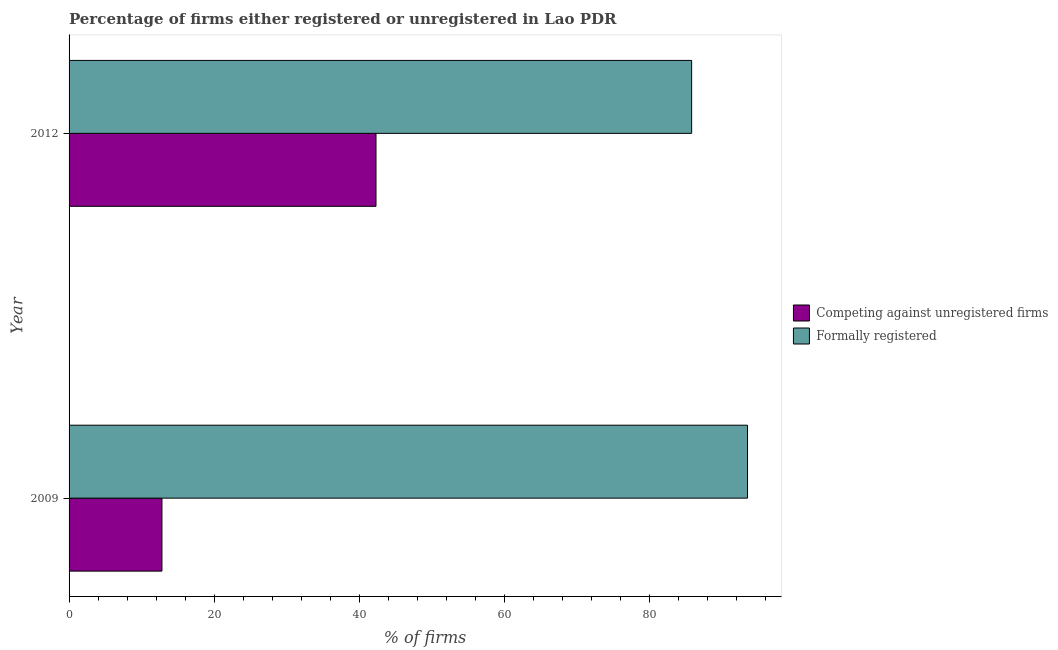How many different coloured bars are there?
Your response must be concise. 2. Are the number of bars per tick equal to the number of legend labels?
Ensure brevity in your answer.  Yes. How many bars are there on the 2nd tick from the top?
Provide a short and direct response. 2. How many bars are there on the 2nd tick from the bottom?
Provide a succinct answer. 2. In how many cases, is the number of bars for a given year not equal to the number of legend labels?
Offer a very short reply. 0. What is the percentage of formally registered firms in 2012?
Provide a short and direct response. 85.8. Across all years, what is the maximum percentage of registered firms?
Your answer should be very brief. 42.3. Across all years, what is the minimum percentage of formally registered firms?
Offer a very short reply. 85.8. In which year was the percentage of formally registered firms minimum?
Your answer should be compact. 2012. What is the total percentage of registered firms in the graph?
Offer a very short reply. 55.1. What is the difference between the percentage of registered firms in 2009 and that in 2012?
Keep it short and to the point. -29.5. What is the difference between the percentage of registered firms in 2009 and the percentage of formally registered firms in 2012?
Your answer should be compact. -73. What is the average percentage of registered firms per year?
Your answer should be compact. 27.55. In the year 2009, what is the difference between the percentage of registered firms and percentage of formally registered firms?
Your answer should be very brief. -80.7. In how many years, is the percentage of registered firms greater than 76 %?
Give a very brief answer. 0. What is the ratio of the percentage of registered firms in 2009 to that in 2012?
Your response must be concise. 0.3. Is the percentage of formally registered firms in 2009 less than that in 2012?
Provide a short and direct response. No. In how many years, is the percentage of registered firms greater than the average percentage of registered firms taken over all years?
Keep it short and to the point. 1. What does the 2nd bar from the top in 2009 represents?
Your answer should be very brief. Competing against unregistered firms. What does the 1st bar from the bottom in 2009 represents?
Offer a very short reply. Competing against unregistered firms. Are all the bars in the graph horizontal?
Your response must be concise. Yes. What is the difference between two consecutive major ticks on the X-axis?
Ensure brevity in your answer.  20. Are the values on the major ticks of X-axis written in scientific E-notation?
Make the answer very short. No. Where does the legend appear in the graph?
Provide a succinct answer. Center right. What is the title of the graph?
Ensure brevity in your answer.  Percentage of firms either registered or unregistered in Lao PDR. What is the label or title of the X-axis?
Make the answer very short. % of firms. What is the % of firms in Formally registered in 2009?
Provide a succinct answer. 93.5. What is the % of firms of Competing against unregistered firms in 2012?
Keep it short and to the point. 42.3. What is the % of firms of Formally registered in 2012?
Provide a succinct answer. 85.8. Across all years, what is the maximum % of firms in Competing against unregistered firms?
Provide a succinct answer. 42.3. Across all years, what is the maximum % of firms in Formally registered?
Provide a short and direct response. 93.5. Across all years, what is the minimum % of firms of Formally registered?
Your response must be concise. 85.8. What is the total % of firms in Competing against unregistered firms in the graph?
Offer a very short reply. 55.1. What is the total % of firms of Formally registered in the graph?
Your response must be concise. 179.3. What is the difference between the % of firms in Competing against unregistered firms in 2009 and that in 2012?
Give a very brief answer. -29.5. What is the difference between the % of firms in Competing against unregistered firms in 2009 and the % of firms in Formally registered in 2012?
Make the answer very short. -73. What is the average % of firms in Competing against unregistered firms per year?
Offer a terse response. 27.55. What is the average % of firms of Formally registered per year?
Give a very brief answer. 89.65. In the year 2009, what is the difference between the % of firms of Competing against unregistered firms and % of firms of Formally registered?
Give a very brief answer. -80.7. In the year 2012, what is the difference between the % of firms of Competing against unregistered firms and % of firms of Formally registered?
Your answer should be compact. -43.5. What is the ratio of the % of firms of Competing against unregistered firms in 2009 to that in 2012?
Make the answer very short. 0.3. What is the ratio of the % of firms in Formally registered in 2009 to that in 2012?
Your answer should be very brief. 1.09. What is the difference between the highest and the second highest % of firms in Competing against unregistered firms?
Your answer should be compact. 29.5. What is the difference between the highest and the second highest % of firms in Formally registered?
Offer a terse response. 7.7. What is the difference between the highest and the lowest % of firms of Competing against unregistered firms?
Ensure brevity in your answer.  29.5. What is the difference between the highest and the lowest % of firms of Formally registered?
Your answer should be compact. 7.7. 